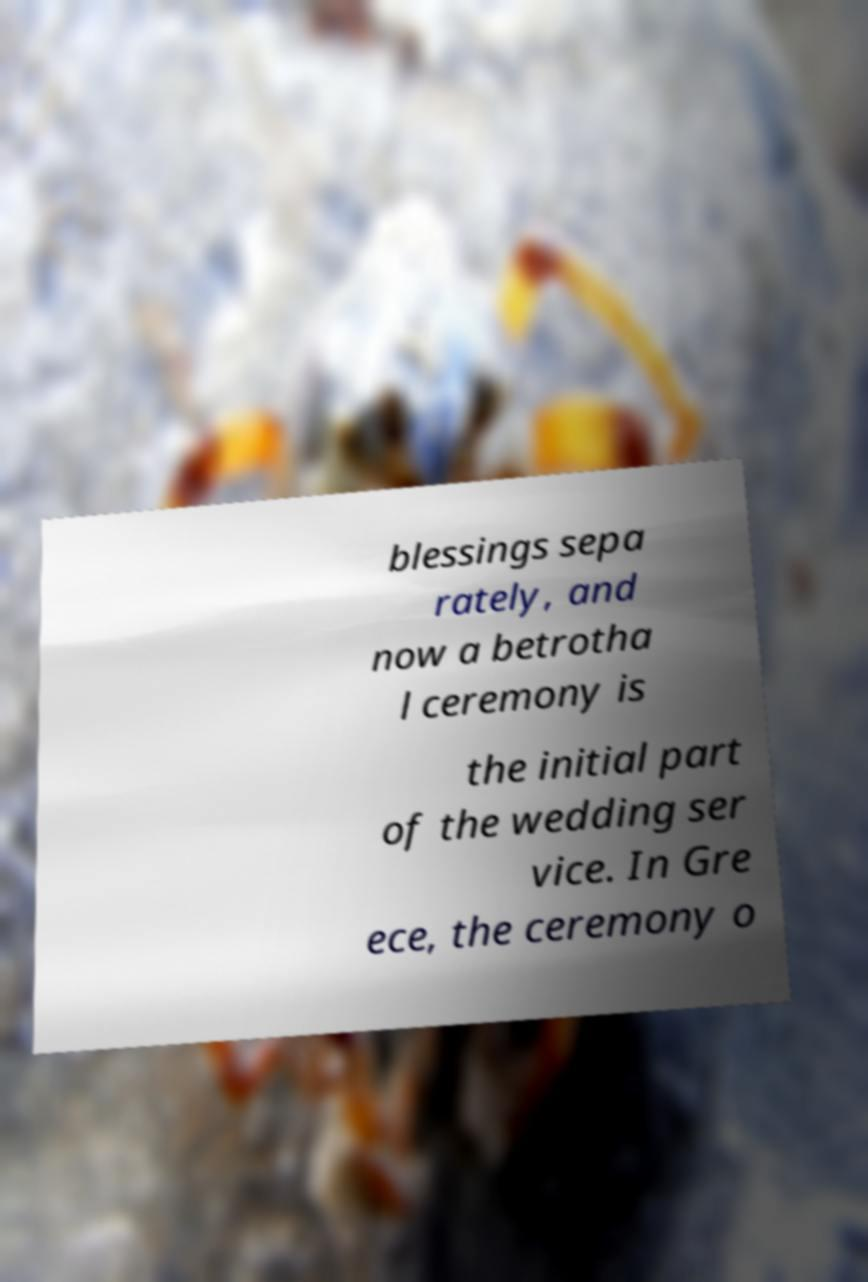Can you read and provide the text displayed in the image?This photo seems to have some interesting text. Can you extract and type it out for me? blessings sepa rately, and now a betrotha l ceremony is the initial part of the wedding ser vice. In Gre ece, the ceremony o 